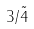Convert formula to latex. <formula><loc_0><loc_0><loc_500><loc_500>3 / \tilde { 4 }</formula> 